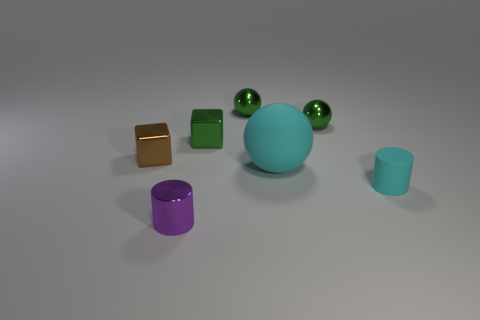Add 1 tiny matte blocks. How many objects exist? 8 Subtract all cylinders. How many objects are left? 5 Subtract 1 cyan cylinders. How many objects are left? 6 Subtract all small purple things. Subtract all big things. How many objects are left? 5 Add 6 small metallic cylinders. How many small metallic cylinders are left? 7 Add 7 cyan cylinders. How many cyan cylinders exist? 8 